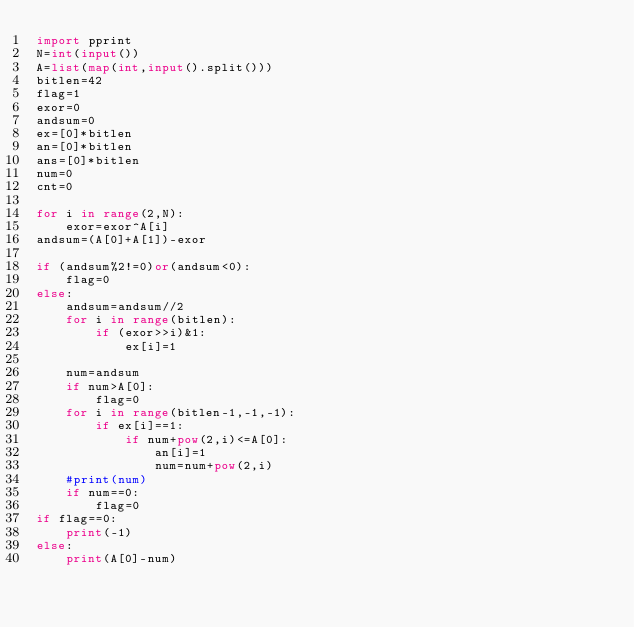Convert code to text. <code><loc_0><loc_0><loc_500><loc_500><_Python_>import pprint
N=int(input())
A=list(map(int,input().split()))
bitlen=42
flag=1
exor=0
andsum=0
ex=[0]*bitlen
an=[0]*bitlen
ans=[0]*bitlen
num=0
cnt=0

for i in range(2,N):
    exor=exor^A[i]
andsum=(A[0]+A[1])-exor

if (andsum%2!=0)or(andsum<0):
    flag=0
else:
    andsum=andsum//2
    for i in range(bitlen):
        if (exor>>i)&1:
            ex[i]=1

    num=andsum
    if num>A[0]:
        flag=0
    for i in range(bitlen-1,-1,-1):
        if ex[i]==1:
            if num+pow(2,i)<=A[0]:
                an[i]=1
                num=num+pow(2,i)
    #print(num)
    if num==0:
        flag=0
if flag==0:
    print(-1)
else:
    print(A[0]-num)
</code> 